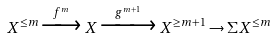<formula> <loc_0><loc_0><loc_500><loc_500>X ^ { \leq m } \xrightarrow { f ^ { m } } X \xrightarrow { g ^ { m + 1 } } X ^ { \geq m + 1 } \rightarrow \Sigma X ^ { \leq m }</formula> 